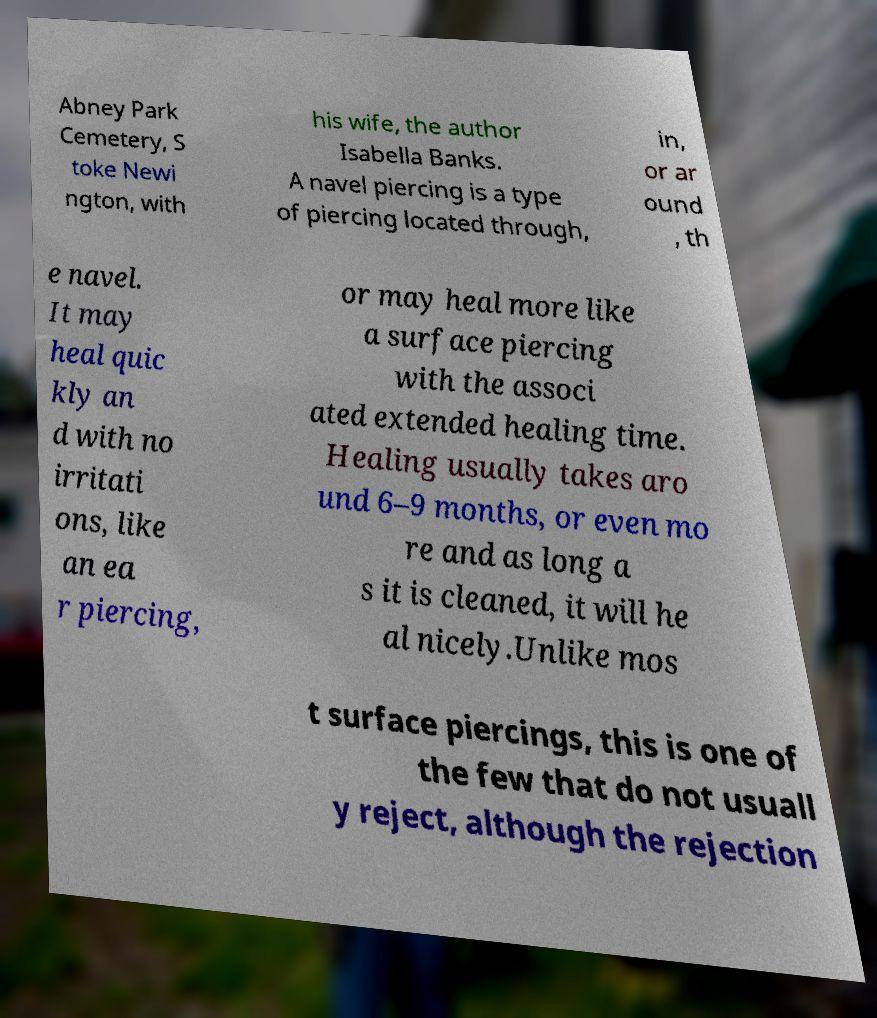I need the written content from this picture converted into text. Can you do that? Abney Park Cemetery, S toke Newi ngton, with his wife, the author Isabella Banks. A navel piercing is a type of piercing located through, in, or ar ound , th e navel. It may heal quic kly an d with no irritati ons, like an ea r piercing, or may heal more like a surface piercing with the associ ated extended healing time. Healing usually takes aro und 6–9 months, or even mo re and as long a s it is cleaned, it will he al nicely.Unlike mos t surface piercings, this is one of the few that do not usuall y reject, although the rejection 